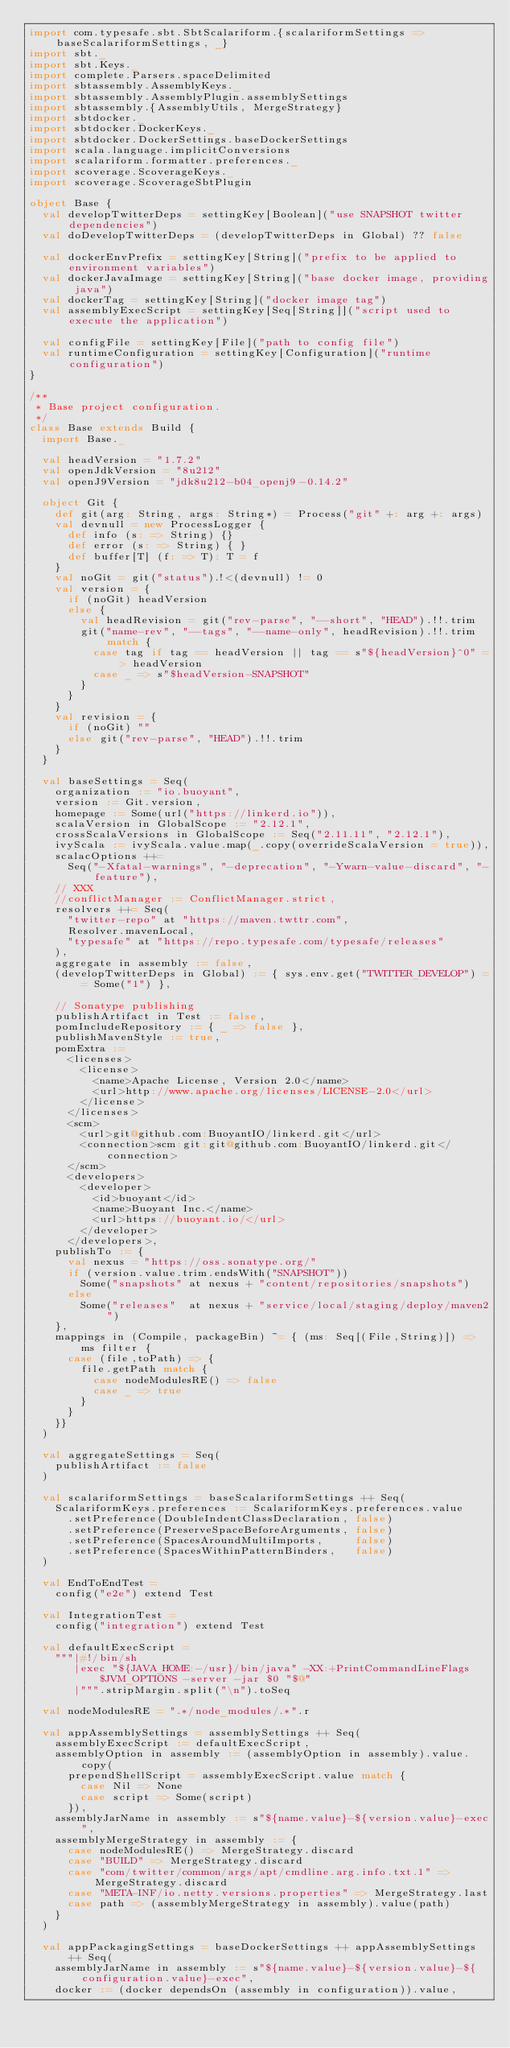<code> <loc_0><loc_0><loc_500><loc_500><_Scala_>import com.typesafe.sbt.SbtScalariform.{scalariformSettings => baseScalariformSettings, _}
import sbt._
import sbt.Keys._
import complete.Parsers.spaceDelimited
import sbtassembly.AssemblyKeys._
import sbtassembly.AssemblyPlugin.assemblySettings
import sbtassembly.{AssemblyUtils, MergeStrategy}
import sbtdocker._
import sbtdocker.DockerKeys._
import sbtdocker.DockerSettings.baseDockerSettings
import scala.language.implicitConversions
import scalariform.formatter.preferences._
import scoverage.ScoverageKeys._
import scoverage.ScoverageSbtPlugin

object Base {
  val developTwitterDeps = settingKey[Boolean]("use SNAPSHOT twitter dependencies")
  val doDevelopTwitterDeps = (developTwitterDeps in Global) ?? false

  val dockerEnvPrefix = settingKey[String]("prefix to be applied to environment variables")
  val dockerJavaImage = settingKey[String]("base docker image, providing java")
  val dockerTag = settingKey[String]("docker image tag")
  val assemblyExecScript = settingKey[Seq[String]]("script used to execute the application")

  val configFile = settingKey[File]("path to config file")
  val runtimeConfiguration = settingKey[Configuration]("runtime configuration")
}

/**
 * Base project configuration.
 */
class Base extends Build {
  import Base._

  val headVersion = "1.7.2"
  val openJdkVersion = "8u212"
  val openJ9Version = "jdk8u212-b04_openj9-0.14.2"

  object Git {
    def git(arg: String, args: String*) = Process("git" +: arg +: args)
    val devnull = new ProcessLogger {
      def info (s: => String) {}
      def error (s: => String) { }
      def buffer[T] (f: => T): T = f
    }
    val noGit = git("status").!<(devnull) != 0
    val version = {
      if (noGit) headVersion
      else {
        val headRevision = git("rev-parse", "--short", "HEAD").!!.trim
        git("name-rev", "--tags", "--name-only", headRevision).!!.trim match {
          case tag if tag == headVersion || tag == s"${headVersion}^0" => headVersion
          case _ => s"$headVersion-SNAPSHOT"
        }
      }
    }
    val revision = {
      if (noGit) ""
      else git("rev-parse", "HEAD").!!.trim
    }
  }

  val baseSettings = Seq(
    organization := "io.buoyant",
    version := Git.version,
    homepage := Some(url("https://linkerd.io")),
    scalaVersion in GlobalScope := "2.12.1",
    crossScalaVersions in GlobalScope := Seq("2.11.11", "2.12.1"),
    ivyScala := ivyScala.value.map(_.copy(overrideScalaVersion = true)),
    scalacOptions ++=
      Seq("-Xfatal-warnings", "-deprecation", "-Ywarn-value-discard", "-feature"),
    // XXX
    //conflictManager := ConflictManager.strict,
    resolvers ++= Seq(
      "twitter-repo" at "https://maven.twttr.com",
      Resolver.mavenLocal,
      "typesafe" at "https://repo.typesafe.com/typesafe/releases"
    ),
    aggregate in assembly := false,
    (developTwitterDeps in Global) := { sys.env.get("TWITTER_DEVELOP") == Some("1") },

    // Sonatype publishing
    publishArtifact in Test := false,
    pomIncludeRepository := { _ => false },
    publishMavenStyle := true,
    pomExtra :=
      <licenses>
        <license>
          <name>Apache License, Version 2.0</name>
          <url>http://www.apache.org/licenses/LICENSE-2.0</url>
        </license>
      </licenses>
      <scm>
        <url>git@github.com:BuoyantIO/linkerd.git</url>
        <connection>scm:git:git@github.com:BuoyantIO/linkerd.git</connection>
      </scm>
      <developers>
        <developer>
          <id>buoyant</id>
          <name>Buoyant Inc.</name>
          <url>https://buoyant.io/</url>
        </developer>
      </developers>,
    publishTo := {
      val nexus = "https://oss.sonatype.org/"
      if (version.value.trim.endsWith("SNAPSHOT"))
        Some("snapshots" at nexus + "content/repositories/snapshots")
      else
        Some("releases"  at nexus + "service/local/staging/deploy/maven2")
    },
    mappings in (Compile, packageBin) ~= { (ms: Seq[(File,String)]) => ms filter {
      case (file,toPath) => {
        file.getPath match {
          case nodeModulesRE() => false
          case _ => true
        }
      }
    }}
  )

  val aggregateSettings = Seq(
    publishArtifact := false
  )

  val scalariformSettings = baseScalariformSettings ++ Seq(
    ScalariformKeys.preferences := ScalariformKeys.preferences.value
      .setPreference(DoubleIndentClassDeclaration, false)
      .setPreference(PreserveSpaceBeforeArguments, false)
      .setPreference(SpacesAroundMultiImports,     false)
      .setPreference(SpacesWithinPatternBinders,   false)
  )

  val EndToEndTest =
    config("e2e") extend Test

  val IntegrationTest =
    config("integration") extend Test

  val defaultExecScript =
    """|#!/bin/sh
       |exec "${JAVA_HOME:-/usr}/bin/java" -XX:+PrintCommandLineFlags $JVM_OPTIONS -server -jar $0 "$@"
       |""".stripMargin.split("\n").toSeq

  val nodeModulesRE = ".*/node_modules/.*".r

  val appAssemblySettings = assemblySettings ++ Seq(
    assemblyExecScript := defaultExecScript,
    assemblyOption in assembly := (assemblyOption in assembly).value.copy(
      prependShellScript = assemblyExecScript.value match {
        case Nil => None
        case script => Some(script)
      }),
    assemblyJarName in assembly := s"${name.value}-${version.value}-exec",
    assemblyMergeStrategy in assembly := {
      case nodeModulesRE() => MergeStrategy.discard
      case "BUILD" => MergeStrategy.discard
      case "com/twitter/common/args/apt/cmdline.arg.info.txt.1" => MergeStrategy.discard
      case "META-INF/io.netty.versions.properties" => MergeStrategy.last
      case path => (assemblyMergeStrategy in assembly).value(path)
    }
  )

  val appPackagingSettings = baseDockerSettings ++ appAssemblySettings ++ Seq(
    assemblyJarName in assembly := s"${name.value}-${version.value}-${configuration.value}-exec",
    docker := (docker dependsOn (assembly in configuration)).value,</code> 